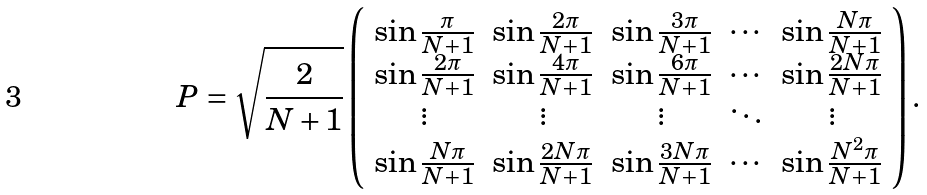Convert formula to latex. <formula><loc_0><loc_0><loc_500><loc_500>P = \sqrt { \frac { 2 } { N + 1 } } \left ( \begin{array} { c c c c c } \sin { \frac { \pi } { N + 1 } } & \sin { \frac { 2 \pi } { N + 1 } } & \sin { \frac { 3 \pi } { N + 1 } } & \cdots & \sin { \frac { N \pi } { N + 1 } } \\ \sin { \frac { 2 \pi } { N + 1 } } & \sin { \frac { 4 \pi } { N + 1 } } & \sin { \frac { 6 \pi } { N + 1 } } & \cdots & \sin { \frac { 2 N \pi } { N + 1 } } \\ \vdots & \vdots & \vdots & \ddots & \vdots \\ \sin { \frac { N \pi } { N + 1 } } & \sin { \frac { 2 N \pi } { N + 1 } } & \sin { \frac { 3 N \pi } { N + 1 } } & \cdots & \sin { \frac { N ^ { 2 } \pi } { N + 1 } } \end{array} \right ) .</formula> 